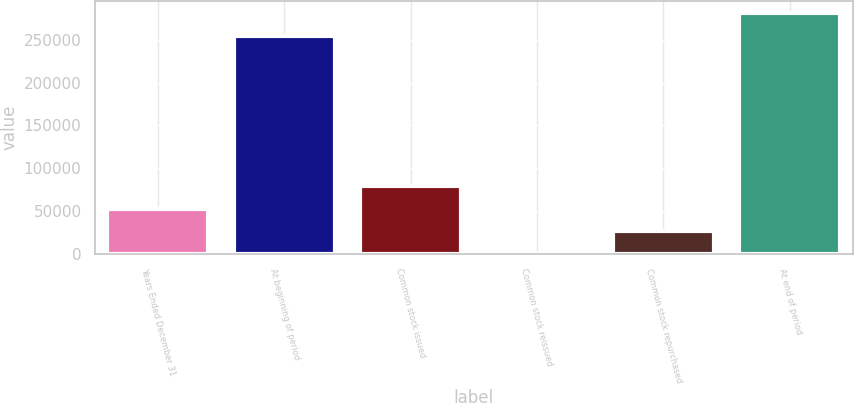Convert chart. <chart><loc_0><loc_0><loc_500><loc_500><bar_chart><fcel>Years Ended December 31<fcel>At beginning of period<fcel>Common stock issued<fcel>Common stock reissued<fcel>Common stock repurchased<fcel>At end of period<nl><fcel>53032<fcel>254100<fcel>79412<fcel>272<fcel>26652<fcel>280480<nl></chart> 